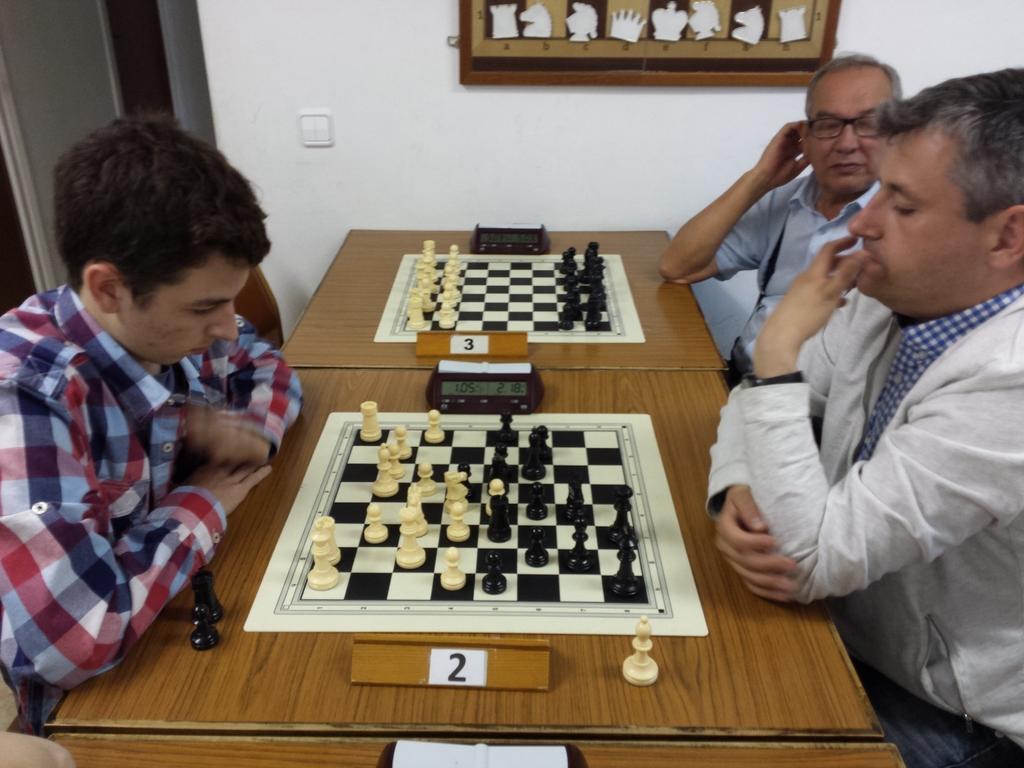Could you give a brief overview of what you see in this image? There are three members sitting around a two tables. Two of them were playing chess which was placed on the table. In the background there is a photo frame attached to the wall. 